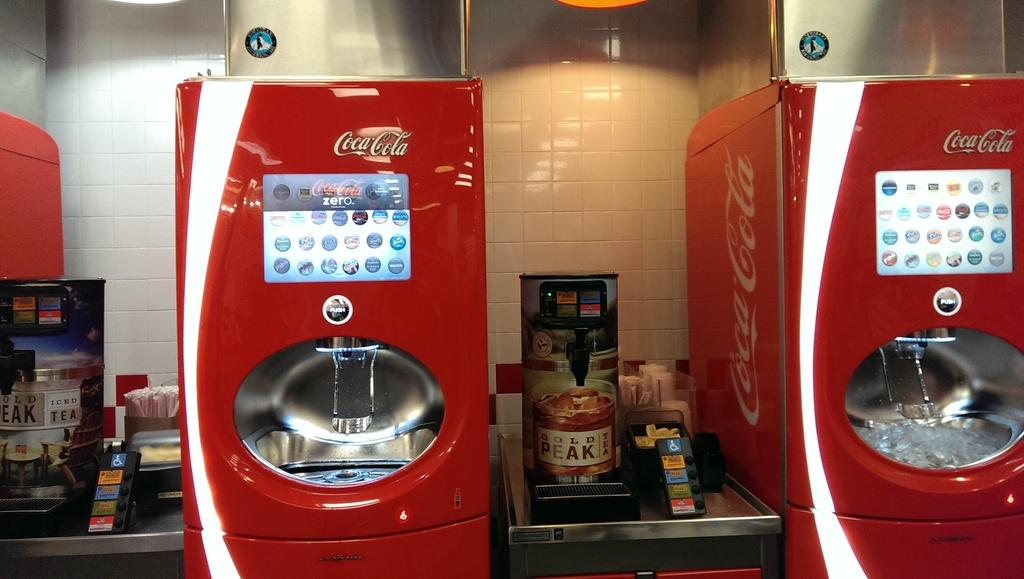Provide a one-sentence caption for the provided image. two red machine with the coca cola logos on the top. 